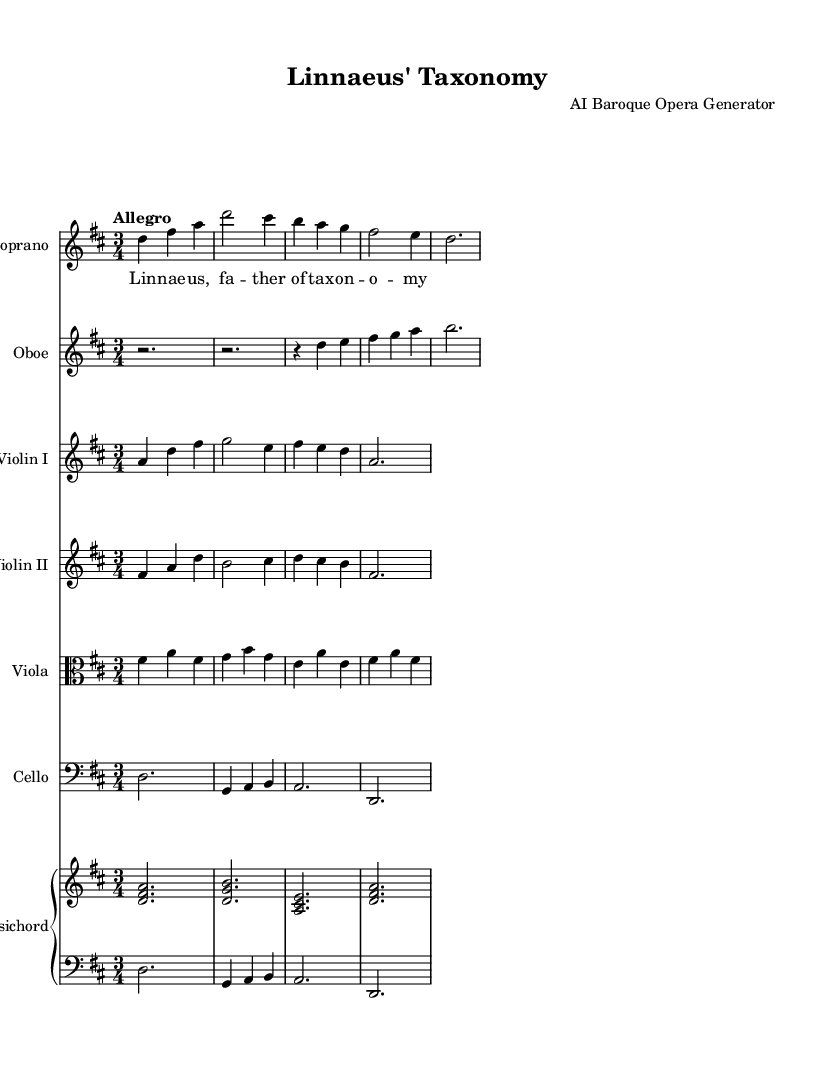What is the key signature of this music? The key signature is D major, indicated by two sharps (F# and C#) in the key signature section at the beginning of the staff.
Answer: D major What is the time signature of this music? The time signature is 3/4, which shows that there are three beats in a measure, and each beat is a quarter note. This is noted at the beginning of the score, just after the key signature.
Answer: 3/4 What is the tempo marking for this piece? The tempo marking is "Allegro," indicating a fast, lively pace, located above the staff in the initial instructions.
Answer: Allegro How many instruments are featured in this score? There are six different instruments listed: Soprano, Oboe, Violin I, Violin II, Viola, Cello, and Harpsichord; each has its own staff.
Answer: Six What is the instrumentation of this piece, starting from the highest to lowest? The instrumentation shows a hierarchy of vocal and instrumental parts starting with Soprano as the highest voice and descending to Cello as the lowest, followed by the Harpsichord.
Answer: Soprano, Oboe, Violin I, Violin II, Viola, Cello, Harpsichord What is the text set to music in this section? The text is "Linnaeus, father of taxonomy," which is stated below the Soprano staff indicating the lyrics for that vocal part.
Answer: Linnaeus, father of taxonomy Which instrument plays the lowest pitch throughout the score? The Cello plays the lowest pitch, indicated by its bass clef designation and its range of notes, which extend lower than the other instruments.
Answer: Cello 